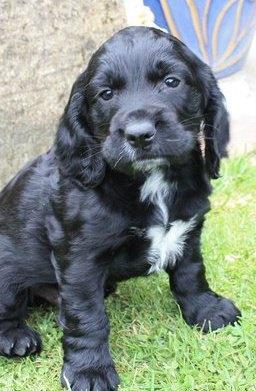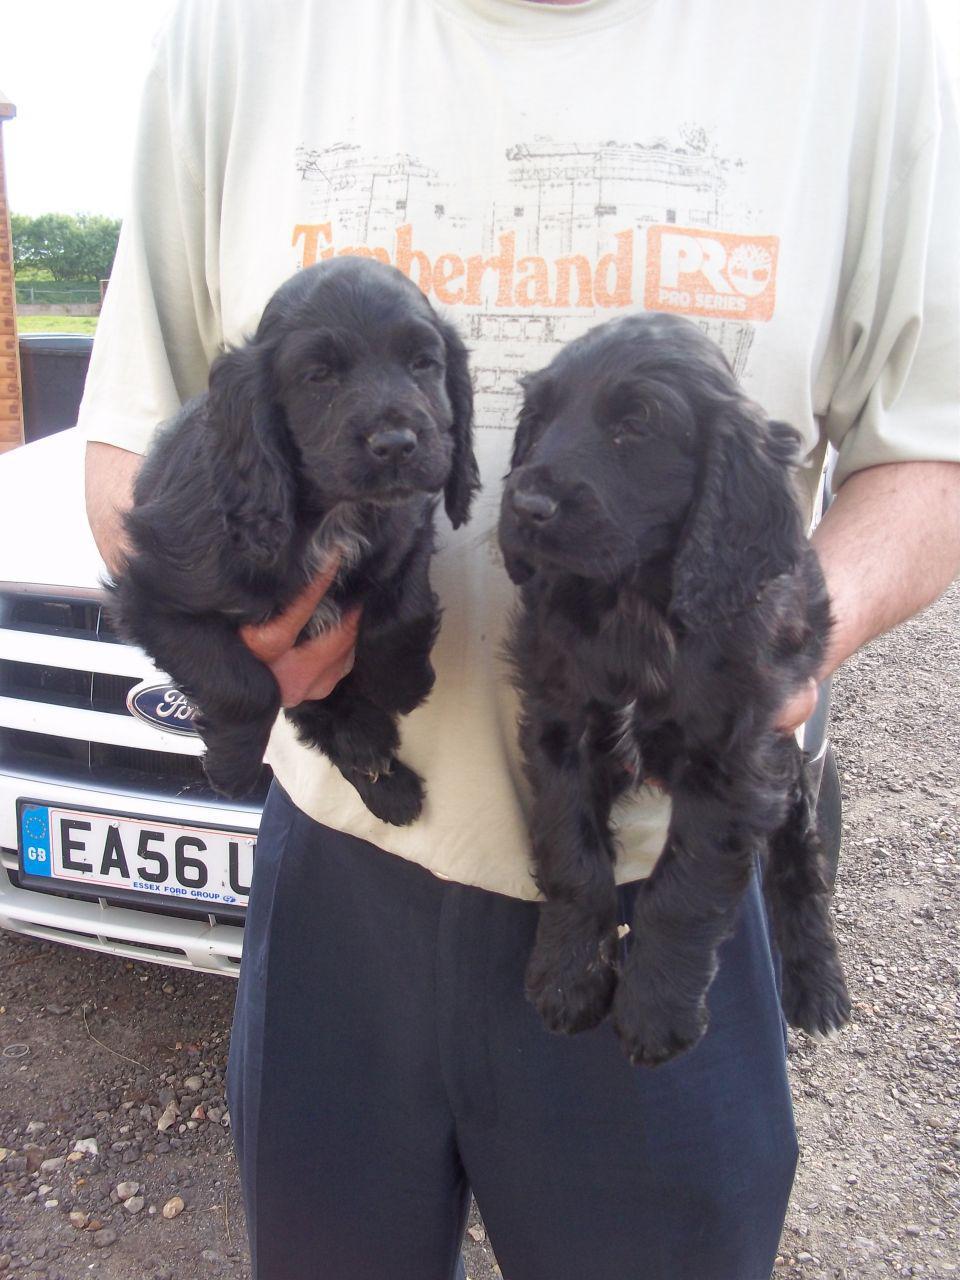The first image is the image on the left, the second image is the image on the right. For the images displayed, is the sentence "There are more black dogs in the right image than in the left." factually correct? Answer yes or no. Yes. The first image is the image on the left, the second image is the image on the right. For the images displayed, is the sentence "The black dog in the image on the left is outside on a sunny day." factually correct? Answer yes or no. Yes. 